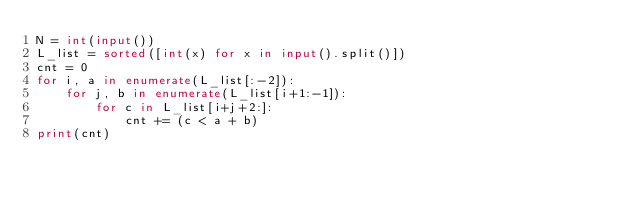<code> <loc_0><loc_0><loc_500><loc_500><_Python_>N = int(input())
L_list = sorted([int(x) for x in input().split()])
cnt = 0
for i, a in enumerate(L_list[:-2]):
    for j, b in enumerate(L_list[i+1:-1]):
        for c in L_list[i+j+2:]:
            cnt += (c < a + b)
print(cnt)
</code> 